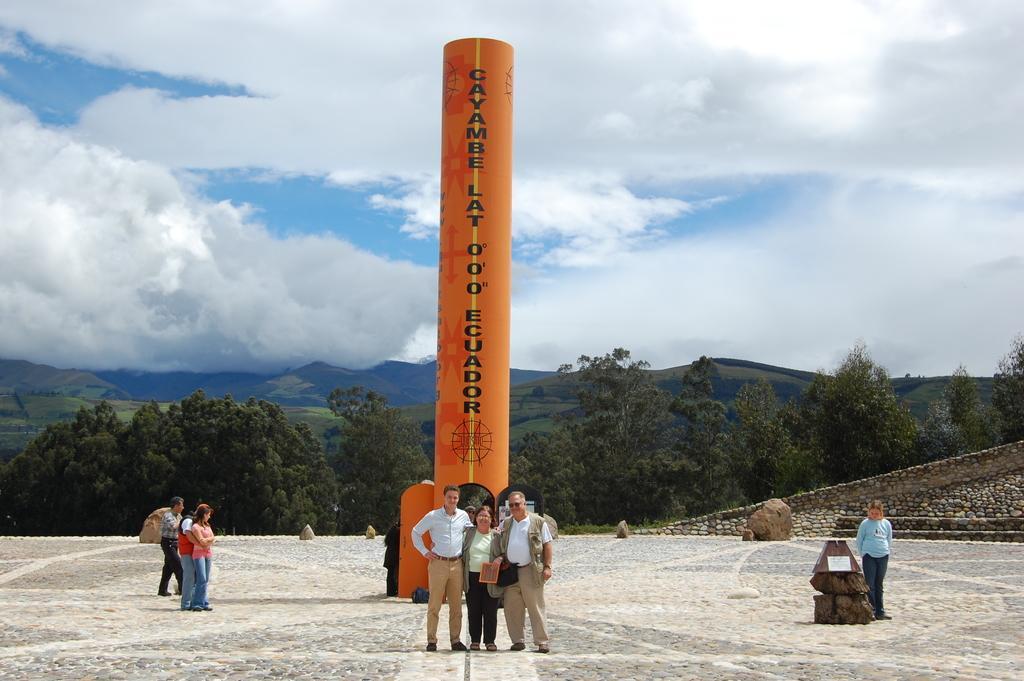Please provide a concise description of this image. In this image there is the sky towards the top of the image, there are clouds in the sky, there are mountains, there are trees, there are group of persons standing, there is a woman holding an object, there is an object that looks like a tower, there is text on the tower, there are rocks on the ground, there is the wall towards the right of the image. 